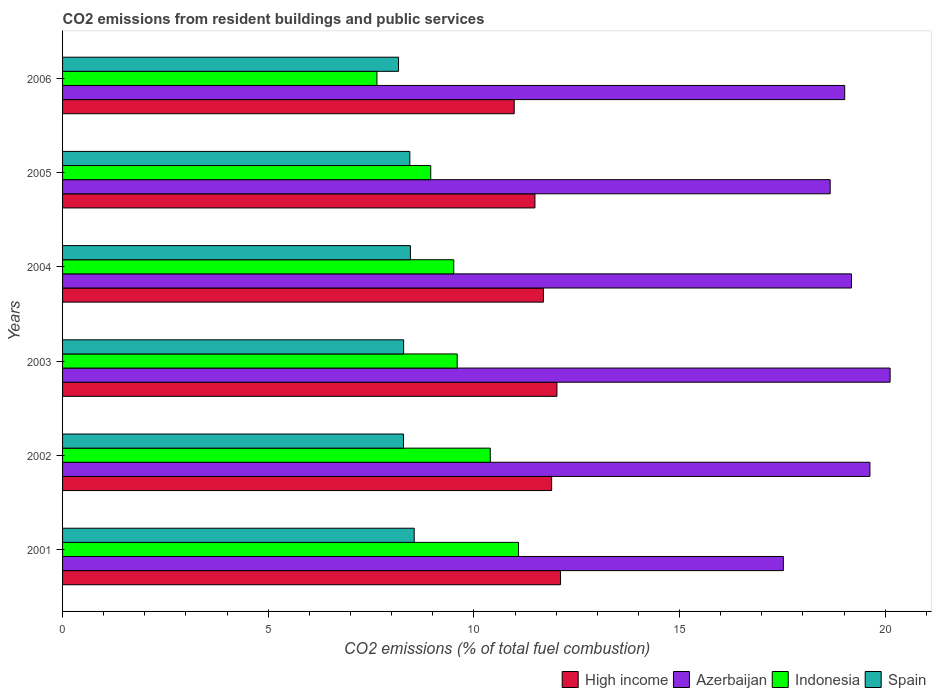How many different coloured bars are there?
Keep it short and to the point. 4. How many groups of bars are there?
Provide a short and direct response. 6. Are the number of bars per tick equal to the number of legend labels?
Offer a terse response. Yes. Are the number of bars on each tick of the Y-axis equal?
Make the answer very short. Yes. How many bars are there on the 2nd tick from the bottom?
Ensure brevity in your answer.  4. What is the label of the 3rd group of bars from the top?
Give a very brief answer. 2004. What is the total CO2 emitted in High income in 2005?
Your answer should be very brief. 11.48. Across all years, what is the maximum total CO2 emitted in Spain?
Make the answer very short. 8.55. Across all years, what is the minimum total CO2 emitted in High income?
Give a very brief answer. 10.98. What is the total total CO2 emitted in High income in the graph?
Your response must be concise. 70.17. What is the difference between the total CO2 emitted in Indonesia in 2003 and that in 2004?
Keep it short and to the point. 0.08. What is the difference between the total CO2 emitted in Azerbaijan in 2001 and the total CO2 emitted in Spain in 2002?
Provide a succinct answer. 9.24. What is the average total CO2 emitted in Azerbaijan per year?
Ensure brevity in your answer.  19.02. In the year 2004, what is the difference between the total CO2 emitted in Spain and total CO2 emitted in Azerbaijan?
Provide a succinct answer. -10.72. In how many years, is the total CO2 emitted in Azerbaijan greater than 5 ?
Make the answer very short. 6. What is the ratio of the total CO2 emitted in Spain in 2003 to that in 2006?
Your response must be concise. 1.02. Is the difference between the total CO2 emitted in Spain in 2002 and 2006 greater than the difference between the total CO2 emitted in Azerbaijan in 2002 and 2006?
Offer a terse response. No. What is the difference between the highest and the second highest total CO2 emitted in Spain?
Keep it short and to the point. 0.09. What is the difference between the highest and the lowest total CO2 emitted in Spain?
Keep it short and to the point. 0.38. In how many years, is the total CO2 emitted in Azerbaijan greater than the average total CO2 emitted in Azerbaijan taken over all years?
Your answer should be compact. 3. Is it the case that in every year, the sum of the total CO2 emitted in High income and total CO2 emitted in Azerbaijan is greater than the sum of total CO2 emitted in Spain and total CO2 emitted in Indonesia?
Your answer should be very brief. No. What does the 4th bar from the bottom in 2003 represents?
Keep it short and to the point. Spain. Is it the case that in every year, the sum of the total CO2 emitted in Spain and total CO2 emitted in Azerbaijan is greater than the total CO2 emitted in High income?
Make the answer very short. Yes. Are all the bars in the graph horizontal?
Your answer should be very brief. Yes. How many years are there in the graph?
Ensure brevity in your answer.  6. Does the graph contain grids?
Offer a terse response. No. What is the title of the graph?
Keep it short and to the point. CO2 emissions from resident buildings and public services. What is the label or title of the X-axis?
Your response must be concise. CO2 emissions (% of total fuel combustion). What is the CO2 emissions (% of total fuel combustion) of High income in 2001?
Your response must be concise. 12.11. What is the CO2 emissions (% of total fuel combustion) in Azerbaijan in 2001?
Your answer should be very brief. 17.52. What is the CO2 emissions (% of total fuel combustion) in Indonesia in 2001?
Make the answer very short. 11.09. What is the CO2 emissions (% of total fuel combustion) of Spain in 2001?
Offer a terse response. 8.55. What is the CO2 emissions (% of total fuel combustion) in High income in 2002?
Your answer should be very brief. 11.89. What is the CO2 emissions (% of total fuel combustion) in Azerbaijan in 2002?
Your response must be concise. 19.63. What is the CO2 emissions (% of total fuel combustion) in Indonesia in 2002?
Offer a terse response. 10.4. What is the CO2 emissions (% of total fuel combustion) in Spain in 2002?
Give a very brief answer. 8.29. What is the CO2 emissions (% of total fuel combustion) in High income in 2003?
Your response must be concise. 12.02. What is the CO2 emissions (% of total fuel combustion) of Azerbaijan in 2003?
Give a very brief answer. 20.12. What is the CO2 emissions (% of total fuel combustion) of Indonesia in 2003?
Provide a short and direct response. 9.59. What is the CO2 emissions (% of total fuel combustion) of Spain in 2003?
Offer a very short reply. 8.29. What is the CO2 emissions (% of total fuel combustion) in High income in 2004?
Your answer should be compact. 11.69. What is the CO2 emissions (% of total fuel combustion) in Azerbaijan in 2004?
Offer a terse response. 19.18. What is the CO2 emissions (% of total fuel combustion) of Indonesia in 2004?
Give a very brief answer. 9.51. What is the CO2 emissions (% of total fuel combustion) of Spain in 2004?
Make the answer very short. 8.46. What is the CO2 emissions (% of total fuel combustion) of High income in 2005?
Offer a very short reply. 11.48. What is the CO2 emissions (% of total fuel combustion) in Azerbaijan in 2005?
Make the answer very short. 18.66. What is the CO2 emissions (% of total fuel combustion) in Indonesia in 2005?
Your response must be concise. 8.95. What is the CO2 emissions (% of total fuel combustion) in Spain in 2005?
Provide a succinct answer. 8.44. What is the CO2 emissions (% of total fuel combustion) in High income in 2006?
Offer a very short reply. 10.98. What is the CO2 emissions (% of total fuel combustion) of Azerbaijan in 2006?
Your answer should be compact. 19.02. What is the CO2 emissions (% of total fuel combustion) in Indonesia in 2006?
Offer a very short reply. 7.64. What is the CO2 emissions (% of total fuel combustion) of Spain in 2006?
Give a very brief answer. 8.17. Across all years, what is the maximum CO2 emissions (% of total fuel combustion) of High income?
Offer a terse response. 12.11. Across all years, what is the maximum CO2 emissions (% of total fuel combustion) in Azerbaijan?
Offer a terse response. 20.12. Across all years, what is the maximum CO2 emissions (% of total fuel combustion) of Indonesia?
Your answer should be compact. 11.09. Across all years, what is the maximum CO2 emissions (% of total fuel combustion) in Spain?
Your answer should be compact. 8.55. Across all years, what is the minimum CO2 emissions (% of total fuel combustion) of High income?
Make the answer very short. 10.98. Across all years, what is the minimum CO2 emissions (% of total fuel combustion) of Azerbaijan?
Keep it short and to the point. 17.52. Across all years, what is the minimum CO2 emissions (% of total fuel combustion) of Indonesia?
Your response must be concise. 7.64. Across all years, what is the minimum CO2 emissions (% of total fuel combustion) of Spain?
Give a very brief answer. 8.17. What is the total CO2 emissions (% of total fuel combustion) of High income in the graph?
Provide a short and direct response. 70.17. What is the total CO2 emissions (% of total fuel combustion) in Azerbaijan in the graph?
Your response must be concise. 114.13. What is the total CO2 emissions (% of total fuel combustion) of Indonesia in the graph?
Make the answer very short. 57.18. What is the total CO2 emissions (% of total fuel combustion) in Spain in the graph?
Your answer should be compact. 50.2. What is the difference between the CO2 emissions (% of total fuel combustion) of High income in 2001 and that in 2002?
Ensure brevity in your answer.  0.22. What is the difference between the CO2 emissions (% of total fuel combustion) in Azerbaijan in 2001 and that in 2002?
Make the answer very short. -2.1. What is the difference between the CO2 emissions (% of total fuel combustion) in Indonesia in 2001 and that in 2002?
Provide a short and direct response. 0.69. What is the difference between the CO2 emissions (% of total fuel combustion) of Spain in 2001 and that in 2002?
Your answer should be compact. 0.26. What is the difference between the CO2 emissions (% of total fuel combustion) in High income in 2001 and that in 2003?
Keep it short and to the point. 0.09. What is the difference between the CO2 emissions (% of total fuel combustion) of Azerbaijan in 2001 and that in 2003?
Offer a very short reply. -2.6. What is the difference between the CO2 emissions (% of total fuel combustion) in Indonesia in 2001 and that in 2003?
Give a very brief answer. 1.49. What is the difference between the CO2 emissions (% of total fuel combustion) of Spain in 2001 and that in 2003?
Offer a very short reply. 0.26. What is the difference between the CO2 emissions (% of total fuel combustion) of High income in 2001 and that in 2004?
Ensure brevity in your answer.  0.42. What is the difference between the CO2 emissions (% of total fuel combustion) in Azerbaijan in 2001 and that in 2004?
Keep it short and to the point. -1.66. What is the difference between the CO2 emissions (% of total fuel combustion) in Indonesia in 2001 and that in 2004?
Your response must be concise. 1.58. What is the difference between the CO2 emissions (% of total fuel combustion) of Spain in 2001 and that in 2004?
Offer a terse response. 0.09. What is the difference between the CO2 emissions (% of total fuel combustion) in High income in 2001 and that in 2005?
Offer a very short reply. 0.62. What is the difference between the CO2 emissions (% of total fuel combustion) in Azerbaijan in 2001 and that in 2005?
Offer a very short reply. -1.14. What is the difference between the CO2 emissions (% of total fuel combustion) of Indonesia in 2001 and that in 2005?
Your response must be concise. 2.13. What is the difference between the CO2 emissions (% of total fuel combustion) in Spain in 2001 and that in 2005?
Your response must be concise. 0.11. What is the difference between the CO2 emissions (% of total fuel combustion) in High income in 2001 and that in 2006?
Ensure brevity in your answer.  1.13. What is the difference between the CO2 emissions (% of total fuel combustion) in Azerbaijan in 2001 and that in 2006?
Ensure brevity in your answer.  -1.49. What is the difference between the CO2 emissions (% of total fuel combustion) in Indonesia in 2001 and that in 2006?
Your response must be concise. 3.44. What is the difference between the CO2 emissions (% of total fuel combustion) in Spain in 2001 and that in 2006?
Your response must be concise. 0.38. What is the difference between the CO2 emissions (% of total fuel combustion) of High income in 2002 and that in 2003?
Keep it short and to the point. -0.13. What is the difference between the CO2 emissions (% of total fuel combustion) in Azerbaijan in 2002 and that in 2003?
Your answer should be very brief. -0.49. What is the difference between the CO2 emissions (% of total fuel combustion) in Indonesia in 2002 and that in 2003?
Keep it short and to the point. 0.8. What is the difference between the CO2 emissions (% of total fuel combustion) in Spain in 2002 and that in 2003?
Offer a very short reply. -0. What is the difference between the CO2 emissions (% of total fuel combustion) of High income in 2002 and that in 2004?
Provide a succinct answer. 0.2. What is the difference between the CO2 emissions (% of total fuel combustion) of Azerbaijan in 2002 and that in 2004?
Your answer should be compact. 0.45. What is the difference between the CO2 emissions (% of total fuel combustion) in Indonesia in 2002 and that in 2004?
Your response must be concise. 0.89. What is the difference between the CO2 emissions (% of total fuel combustion) in Spain in 2002 and that in 2004?
Make the answer very short. -0.17. What is the difference between the CO2 emissions (% of total fuel combustion) of High income in 2002 and that in 2005?
Your response must be concise. 0.41. What is the difference between the CO2 emissions (% of total fuel combustion) in Azerbaijan in 2002 and that in 2005?
Offer a terse response. 0.97. What is the difference between the CO2 emissions (% of total fuel combustion) in Indonesia in 2002 and that in 2005?
Your answer should be compact. 1.45. What is the difference between the CO2 emissions (% of total fuel combustion) of Spain in 2002 and that in 2005?
Make the answer very short. -0.15. What is the difference between the CO2 emissions (% of total fuel combustion) in High income in 2002 and that in 2006?
Give a very brief answer. 0.91. What is the difference between the CO2 emissions (% of total fuel combustion) of Azerbaijan in 2002 and that in 2006?
Offer a very short reply. 0.61. What is the difference between the CO2 emissions (% of total fuel combustion) of Indonesia in 2002 and that in 2006?
Your answer should be very brief. 2.76. What is the difference between the CO2 emissions (% of total fuel combustion) of Spain in 2002 and that in 2006?
Give a very brief answer. 0.12. What is the difference between the CO2 emissions (% of total fuel combustion) in High income in 2003 and that in 2004?
Your response must be concise. 0.33. What is the difference between the CO2 emissions (% of total fuel combustion) of Azerbaijan in 2003 and that in 2004?
Your response must be concise. 0.94. What is the difference between the CO2 emissions (% of total fuel combustion) in Indonesia in 2003 and that in 2004?
Offer a terse response. 0.08. What is the difference between the CO2 emissions (% of total fuel combustion) of Spain in 2003 and that in 2004?
Offer a very short reply. -0.17. What is the difference between the CO2 emissions (% of total fuel combustion) of High income in 2003 and that in 2005?
Offer a very short reply. 0.53. What is the difference between the CO2 emissions (% of total fuel combustion) in Azerbaijan in 2003 and that in 2005?
Provide a short and direct response. 1.46. What is the difference between the CO2 emissions (% of total fuel combustion) in Indonesia in 2003 and that in 2005?
Your answer should be compact. 0.64. What is the difference between the CO2 emissions (% of total fuel combustion) in Spain in 2003 and that in 2005?
Offer a very short reply. -0.15. What is the difference between the CO2 emissions (% of total fuel combustion) of High income in 2003 and that in 2006?
Give a very brief answer. 1.04. What is the difference between the CO2 emissions (% of total fuel combustion) of Azerbaijan in 2003 and that in 2006?
Give a very brief answer. 1.1. What is the difference between the CO2 emissions (% of total fuel combustion) in Indonesia in 2003 and that in 2006?
Ensure brevity in your answer.  1.95. What is the difference between the CO2 emissions (% of total fuel combustion) of Spain in 2003 and that in 2006?
Your answer should be very brief. 0.12. What is the difference between the CO2 emissions (% of total fuel combustion) in High income in 2004 and that in 2005?
Make the answer very short. 0.21. What is the difference between the CO2 emissions (% of total fuel combustion) in Azerbaijan in 2004 and that in 2005?
Keep it short and to the point. 0.52. What is the difference between the CO2 emissions (% of total fuel combustion) in Indonesia in 2004 and that in 2005?
Keep it short and to the point. 0.56. What is the difference between the CO2 emissions (% of total fuel combustion) of Spain in 2004 and that in 2005?
Give a very brief answer. 0.01. What is the difference between the CO2 emissions (% of total fuel combustion) in High income in 2004 and that in 2006?
Give a very brief answer. 0.71. What is the difference between the CO2 emissions (% of total fuel combustion) of Azerbaijan in 2004 and that in 2006?
Offer a very short reply. 0.16. What is the difference between the CO2 emissions (% of total fuel combustion) of Indonesia in 2004 and that in 2006?
Offer a very short reply. 1.87. What is the difference between the CO2 emissions (% of total fuel combustion) in Spain in 2004 and that in 2006?
Your answer should be compact. 0.29. What is the difference between the CO2 emissions (% of total fuel combustion) of High income in 2005 and that in 2006?
Offer a very short reply. 0.5. What is the difference between the CO2 emissions (% of total fuel combustion) of Azerbaijan in 2005 and that in 2006?
Make the answer very short. -0.35. What is the difference between the CO2 emissions (% of total fuel combustion) in Indonesia in 2005 and that in 2006?
Keep it short and to the point. 1.31. What is the difference between the CO2 emissions (% of total fuel combustion) in Spain in 2005 and that in 2006?
Make the answer very short. 0.27. What is the difference between the CO2 emissions (% of total fuel combustion) of High income in 2001 and the CO2 emissions (% of total fuel combustion) of Azerbaijan in 2002?
Your answer should be very brief. -7.52. What is the difference between the CO2 emissions (% of total fuel combustion) of High income in 2001 and the CO2 emissions (% of total fuel combustion) of Indonesia in 2002?
Offer a very short reply. 1.71. What is the difference between the CO2 emissions (% of total fuel combustion) of High income in 2001 and the CO2 emissions (% of total fuel combustion) of Spain in 2002?
Your answer should be compact. 3.82. What is the difference between the CO2 emissions (% of total fuel combustion) in Azerbaijan in 2001 and the CO2 emissions (% of total fuel combustion) in Indonesia in 2002?
Offer a terse response. 7.13. What is the difference between the CO2 emissions (% of total fuel combustion) of Azerbaijan in 2001 and the CO2 emissions (% of total fuel combustion) of Spain in 2002?
Offer a terse response. 9.24. What is the difference between the CO2 emissions (% of total fuel combustion) in Indonesia in 2001 and the CO2 emissions (% of total fuel combustion) in Spain in 2002?
Your response must be concise. 2.8. What is the difference between the CO2 emissions (% of total fuel combustion) in High income in 2001 and the CO2 emissions (% of total fuel combustion) in Azerbaijan in 2003?
Offer a very short reply. -8.01. What is the difference between the CO2 emissions (% of total fuel combustion) of High income in 2001 and the CO2 emissions (% of total fuel combustion) of Indonesia in 2003?
Your response must be concise. 2.51. What is the difference between the CO2 emissions (% of total fuel combustion) in High income in 2001 and the CO2 emissions (% of total fuel combustion) in Spain in 2003?
Keep it short and to the point. 3.82. What is the difference between the CO2 emissions (% of total fuel combustion) in Azerbaijan in 2001 and the CO2 emissions (% of total fuel combustion) in Indonesia in 2003?
Offer a very short reply. 7.93. What is the difference between the CO2 emissions (% of total fuel combustion) of Azerbaijan in 2001 and the CO2 emissions (% of total fuel combustion) of Spain in 2003?
Offer a very short reply. 9.23. What is the difference between the CO2 emissions (% of total fuel combustion) of Indonesia in 2001 and the CO2 emissions (% of total fuel combustion) of Spain in 2003?
Offer a terse response. 2.79. What is the difference between the CO2 emissions (% of total fuel combustion) in High income in 2001 and the CO2 emissions (% of total fuel combustion) in Azerbaijan in 2004?
Give a very brief answer. -7.07. What is the difference between the CO2 emissions (% of total fuel combustion) in High income in 2001 and the CO2 emissions (% of total fuel combustion) in Indonesia in 2004?
Your answer should be compact. 2.6. What is the difference between the CO2 emissions (% of total fuel combustion) in High income in 2001 and the CO2 emissions (% of total fuel combustion) in Spain in 2004?
Keep it short and to the point. 3.65. What is the difference between the CO2 emissions (% of total fuel combustion) in Azerbaijan in 2001 and the CO2 emissions (% of total fuel combustion) in Indonesia in 2004?
Offer a terse response. 8.01. What is the difference between the CO2 emissions (% of total fuel combustion) in Azerbaijan in 2001 and the CO2 emissions (% of total fuel combustion) in Spain in 2004?
Ensure brevity in your answer.  9.07. What is the difference between the CO2 emissions (% of total fuel combustion) in Indonesia in 2001 and the CO2 emissions (% of total fuel combustion) in Spain in 2004?
Your response must be concise. 2.63. What is the difference between the CO2 emissions (% of total fuel combustion) in High income in 2001 and the CO2 emissions (% of total fuel combustion) in Azerbaijan in 2005?
Give a very brief answer. -6.56. What is the difference between the CO2 emissions (% of total fuel combustion) of High income in 2001 and the CO2 emissions (% of total fuel combustion) of Indonesia in 2005?
Provide a succinct answer. 3.16. What is the difference between the CO2 emissions (% of total fuel combustion) of High income in 2001 and the CO2 emissions (% of total fuel combustion) of Spain in 2005?
Your answer should be very brief. 3.66. What is the difference between the CO2 emissions (% of total fuel combustion) in Azerbaijan in 2001 and the CO2 emissions (% of total fuel combustion) in Indonesia in 2005?
Give a very brief answer. 8.57. What is the difference between the CO2 emissions (% of total fuel combustion) in Azerbaijan in 2001 and the CO2 emissions (% of total fuel combustion) in Spain in 2005?
Offer a very short reply. 9.08. What is the difference between the CO2 emissions (% of total fuel combustion) in Indonesia in 2001 and the CO2 emissions (% of total fuel combustion) in Spain in 2005?
Make the answer very short. 2.64. What is the difference between the CO2 emissions (% of total fuel combustion) in High income in 2001 and the CO2 emissions (% of total fuel combustion) in Azerbaijan in 2006?
Provide a short and direct response. -6.91. What is the difference between the CO2 emissions (% of total fuel combustion) in High income in 2001 and the CO2 emissions (% of total fuel combustion) in Indonesia in 2006?
Give a very brief answer. 4.46. What is the difference between the CO2 emissions (% of total fuel combustion) in High income in 2001 and the CO2 emissions (% of total fuel combustion) in Spain in 2006?
Your answer should be very brief. 3.94. What is the difference between the CO2 emissions (% of total fuel combustion) in Azerbaijan in 2001 and the CO2 emissions (% of total fuel combustion) in Indonesia in 2006?
Provide a short and direct response. 9.88. What is the difference between the CO2 emissions (% of total fuel combustion) of Azerbaijan in 2001 and the CO2 emissions (% of total fuel combustion) of Spain in 2006?
Your response must be concise. 9.36. What is the difference between the CO2 emissions (% of total fuel combustion) in Indonesia in 2001 and the CO2 emissions (% of total fuel combustion) in Spain in 2006?
Provide a short and direct response. 2.92. What is the difference between the CO2 emissions (% of total fuel combustion) of High income in 2002 and the CO2 emissions (% of total fuel combustion) of Azerbaijan in 2003?
Provide a succinct answer. -8.23. What is the difference between the CO2 emissions (% of total fuel combustion) in High income in 2002 and the CO2 emissions (% of total fuel combustion) in Indonesia in 2003?
Ensure brevity in your answer.  2.3. What is the difference between the CO2 emissions (% of total fuel combustion) of High income in 2002 and the CO2 emissions (% of total fuel combustion) of Spain in 2003?
Your answer should be compact. 3.6. What is the difference between the CO2 emissions (% of total fuel combustion) in Azerbaijan in 2002 and the CO2 emissions (% of total fuel combustion) in Indonesia in 2003?
Give a very brief answer. 10.04. What is the difference between the CO2 emissions (% of total fuel combustion) in Azerbaijan in 2002 and the CO2 emissions (% of total fuel combustion) in Spain in 2003?
Offer a terse response. 11.34. What is the difference between the CO2 emissions (% of total fuel combustion) in Indonesia in 2002 and the CO2 emissions (% of total fuel combustion) in Spain in 2003?
Provide a succinct answer. 2.11. What is the difference between the CO2 emissions (% of total fuel combustion) in High income in 2002 and the CO2 emissions (% of total fuel combustion) in Azerbaijan in 2004?
Your answer should be very brief. -7.29. What is the difference between the CO2 emissions (% of total fuel combustion) of High income in 2002 and the CO2 emissions (% of total fuel combustion) of Indonesia in 2004?
Provide a succinct answer. 2.38. What is the difference between the CO2 emissions (% of total fuel combustion) in High income in 2002 and the CO2 emissions (% of total fuel combustion) in Spain in 2004?
Give a very brief answer. 3.43. What is the difference between the CO2 emissions (% of total fuel combustion) in Azerbaijan in 2002 and the CO2 emissions (% of total fuel combustion) in Indonesia in 2004?
Make the answer very short. 10.12. What is the difference between the CO2 emissions (% of total fuel combustion) in Azerbaijan in 2002 and the CO2 emissions (% of total fuel combustion) in Spain in 2004?
Provide a short and direct response. 11.17. What is the difference between the CO2 emissions (% of total fuel combustion) of Indonesia in 2002 and the CO2 emissions (% of total fuel combustion) of Spain in 2004?
Offer a terse response. 1.94. What is the difference between the CO2 emissions (% of total fuel combustion) in High income in 2002 and the CO2 emissions (% of total fuel combustion) in Azerbaijan in 2005?
Your response must be concise. -6.77. What is the difference between the CO2 emissions (% of total fuel combustion) in High income in 2002 and the CO2 emissions (% of total fuel combustion) in Indonesia in 2005?
Your answer should be very brief. 2.94. What is the difference between the CO2 emissions (% of total fuel combustion) of High income in 2002 and the CO2 emissions (% of total fuel combustion) of Spain in 2005?
Your response must be concise. 3.45. What is the difference between the CO2 emissions (% of total fuel combustion) of Azerbaijan in 2002 and the CO2 emissions (% of total fuel combustion) of Indonesia in 2005?
Keep it short and to the point. 10.68. What is the difference between the CO2 emissions (% of total fuel combustion) of Azerbaijan in 2002 and the CO2 emissions (% of total fuel combustion) of Spain in 2005?
Your answer should be very brief. 11.19. What is the difference between the CO2 emissions (% of total fuel combustion) of Indonesia in 2002 and the CO2 emissions (% of total fuel combustion) of Spain in 2005?
Your answer should be compact. 1.96. What is the difference between the CO2 emissions (% of total fuel combustion) in High income in 2002 and the CO2 emissions (% of total fuel combustion) in Azerbaijan in 2006?
Your response must be concise. -7.13. What is the difference between the CO2 emissions (% of total fuel combustion) in High income in 2002 and the CO2 emissions (% of total fuel combustion) in Indonesia in 2006?
Ensure brevity in your answer.  4.25. What is the difference between the CO2 emissions (% of total fuel combustion) in High income in 2002 and the CO2 emissions (% of total fuel combustion) in Spain in 2006?
Ensure brevity in your answer.  3.72. What is the difference between the CO2 emissions (% of total fuel combustion) of Azerbaijan in 2002 and the CO2 emissions (% of total fuel combustion) of Indonesia in 2006?
Your answer should be very brief. 11.99. What is the difference between the CO2 emissions (% of total fuel combustion) of Azerbaijan in 2002 and the CO2 emissions (% of total fuel combustion) of Spain in 2006?
Your response must be concise. 11.46. What is the difference between the CO2 emissions (% of total fuel combustion) of Indonesia in 2002 and the CO2 emissions (% of total fuel combustion) of Spain in 2006?
Make the answer very short. 2.23. What is the difference between the CO2 emissions (% of total fuel combustion) of High income in 2003 and the CO2 emissions (% of total fuel combustion) of Azerbaijan in 2004?
Give a very brief answer. -7.16. What is the difference between the CO2 emissions (% of total fuel combustion) in High income in 2003 and the CO2 emissions (% of total fuel combustion) in Indonesia in 2004?
Ensure brevity in your answer.  2.51. What is the difference between the CO2 emissions (% of total fuel combustion) in High income in 2003 and the CO2 emissions (% of total fuel combustion) in Spain in 2004?
Offer a terse response. 3.56. What is the difference between the CO2 emissions (% of total fuel combustion) in Azerbaijan in 2003 and the CO2 emissions (% of total fuel combustion) in Indonesia in 2004?
Offer a very short reply. 10.61. What is the difference between the CO2 emissions (% of total fuel combustion) of Azerbaijan in 2003 and the CO2 emissions (% of total fuel combustion) of Spain in 2004?
Offer a terse response. 11.66. What is the difference between the CO2 emissions (% of total fuel combustion) in Indonesia in 2003 and the CO2 emissions (% of total fuel combustion) in Spain in 2004?
Your answer should be compact. 1.14. What is the difference between the CO2 emissions (% of total fuel combustion) of High income in 2003 and the CO2 emissions (% of total fuel combustion) of Azerbaijan in 2005?
Provide a short and direct response. -6.64. What is the difference between the CO2 emissions (% of total fuel combustion) in High income in 2003 and the CO2 emissions (% of total fuel combustion) in Indonesia in 2005?
Ensure brevity in your answer.  3.07. What is the difference between the CO2 emissions (% of total fuel combustion) of High income in 2003 and the CO2 emissions (% of total fuel combustion) of Spain in 2005?
Your response must be concise. 3.58. What is the difference between the CO2 emissions (% of total fuel combustion) of Azerbaijan in 2003 and the CO2 emissions (% of total fuel combustion) of Indonesia in 2005?
Provide a succinct answer. 11.17. What is the difference between the CO2 emissions (% of total fuel combustion) in Azerbaijan in 2003 and the CO2 emissions (% of total fuel combustion) in Spain in 2005?
Provide a short and direct response. 11.68. What is the difference between the CO2 emissions (% of total fuel combustion) of Indonesia in 2003 and the CO2 emissions (% of total fuel combustion) of Spain in 2005?
Keep it short and to the point. 1.15. What is the difference between the CO2 emissions (% of total fuel combustion) of High income in 2003 and the CO2 emissions (% of total fuel combustion) of Azerbaijan in 2006?
Provide a succinct answer. -7. What is the difference between the CO2 emissions (% of total fuel combustion) in High income in 2003 and the CO2 emissions (% of total fuel combustion) in Indonesia in 2006?
Give a very brief answer. 4.38. What is the difference between the CO2 emissions (% of total fuel combustion) of High income in 2003 and the CO2 emissions (% of total fuel combustion) of Spain in 2006?
Offer a terse response. 3.85. What is the difference between the CO2 emissions (% of total fuel combustion) of Azerbaijan in 2003 and the CO2 emissions (% of total fuel combustion) of Indonesia in 2006?
Offer a terse response. 12.48. What is the difference between the CO2 emissions (% of total fuel combustion) in Azerbaijan in 2003 and the CO2 emissions (% of total fuel combustion) in Spain in 2006?
Make the answer very short. 11.95. What is the difference between the CO2 emissions (% of total fuel combustion) in Indonesia in 2003 and the CO2 emissions (% of total fuel combustion) in Spain in 2006?
Make the answer very short. 1.43. What is the difference between the CO2 emissions (% of total fuel combustion) in High income in 2004 and the CO2 emissions (% of total fuel combustion) in Azerbaijan in 2005?
Provide a succinct answer. -6.97. What is the difference between the CO2 emissions (% of total fuel combustion) in High income in 2004 and the CO2 emissions (% of total fuel combustion) in Indonesia in 2005?
Ensure brevity in your answer.  2.74. What is the difference between the CO2 emissions (% of total fuel combustion) of High income in 2004 and the CO2 emissions (% of total fuel combustion) of Spain in 2005?
Provide a short and direct response. 3.25. What is the difference between the CO2 emissions (% of total fuel combustion) in Azerbaijan in 2004 and the CO2 emissions (% of total fuel combustion) in Indonesia in 2005?
Your answer should be very brief. 10.23. What is the difference between the CO2 emissions (% of total fuel combustion) in Azerbaijan in 2004 and the CO2 emissions (% of total fuel combustion) in Spain in 2005?
Offer a terse response. 10.74. What is the difference between the CO2 emissions (% of total fuel combustion) of Indonesia in 2004 and the CO2 emissions (% of total fuel combustion) of Spain in 2005?
Provide a succinct answer. 1.07. What is the difference between the CO2 emissions (% of total fuel combustion) of High income in 2004 and the CO2 emissions (% of total fuel combustion) of Azerbaijan in 2006?
Ensure brevity in your answer.  -7.33. What is the difference between the CO2 emissions (% of total fuel combustion) in High income in 2004 and the CO2 emissions (% of total fuel combustion) in Indonesia in 2006?
Offer a very short reply. 4.05. What is the difference between the CO2 emissions (% of total fuel combustion) in High income in 2004 and the CO2 emissions (% of total fuel combustion) in Spain in 2006?
Offer a very short reply. 3.52. What is the difference between the CO2 emissions (% of total fuel combustion) in Azerbaijan in 2004 and the CO2 emissions (% of total fuel combustion) in Indonesia in 2006?
Make the answer very short. 11.54. What is the difference between the CO2 emissions (% of total fuel combustion) of Azerbaijan in 2004 and the CO2 emissions (% of total fuel combustion) of Spain in 2006?
Ensure brevity in your answer.  11.01. What is the difference between the CO2 emissions (% of total fuel combustion) of Indonesia in 2004 and the CO2 emissions (% of total fuel combustion) of Spain in 2006?
Offer a terse response. 1.34. What is the difference between the CO2 emissions (% of total fuel combustion) of High income in 2005 and the CO2 emissions (% of total fuel combustion) of Azerbaijan in 2006?
Make the answer very short. -7.53. What is the difference between the CO2 emissions (% of total fuel combustion) of High income in 2005 and the CO2 emissions (% of total fuel combustion) of Indonesia in 2006?
Your answer should be compact. 3.84. What is the difference between the CO2 emissions (% of total fuel combustion) of High income in 2005 and the CO2 emissions (% of total fuel combustion) of Spain in 2006?
Offer a very short reply. 3.32. What is the difference between the CO2 emissions (% of total fuel combustion) of Azerbaijan in 2005 and the CO2 emissions (% of total fuel combustion) of Indonesia in 2006?
Offer a very short reply. 11.02. What is the difference between the CO2 emissions (% of total fuel combustion) of Azerbaijan in 2005 and the CO2 emissions (% of total fuel combustion) of Spain in 2006?
Offer a very short reply. 10.49. What is the difference between the CO2 emissions (% of total fuel combustion) in Indonesia in 2005 and the CO2 emissions (% of total fuel combustion) in Spain in 2006?
Your answer should be compact. 0.78. What is the average CO2 emissions (% of total fuel combustion) of High income per year?
Provide a short and direct response. 11.7. What is the average CO2 emissions (% of total fuel combustion) of Azerbaijan per year?
Provide a short and direct response. 19.02. What is the average CO2 emissions (% of total fuel combustion) in Indonesia per year?
Offer a terse response. 9.53. What is the average CO2 emissions (% of total fuel combustion) in Spain per year?
Keep it short and to the point. 8.37. In the year 2001, what is the difference between the CO2 emissions (% of total fuel combustion) of High income and CO2 emissions (% of total fuel combustion) of Azerbaijan?
Your answer should be compact. -5.42. In the year 2001, what is the difference between the CO2 emissions (% of total fuel combustion) of High income and CO2 emissions (% of total fuel combustion) of Indonesia?
Provide a succinct answer. 1.02. In the year 2001, what is the difference between the CO2 emissions (% of total fuel combustion) of High income and CO2 emissions (% of total fuel combustion) of Spain?
Your answer should be very brief. 3.56. In the year 2001, what is the difference between the CO2 emissions (% of total fuel combustion) of Azerbaijan and CO2 emissions (% of total fuel combustion) of Indonesia?
Provide a succinct answer. 6.44. In the year 2001, what is the difference between the CO2 emissions (% of total fuel combustion) in Azerbaijan and CO2 emissions (% of total fuel combustion) in Spain?
Your response must be concise. 8.98. In the year 2001, what is the difference between the CO2 emissions (% of total fuel combustion) in Indonesia and CO2 emissions (% of total fuel combustion) in Spain?
Keep it short and to the point. 2.54. In the year 2002, what is the difference between the CO2 emissions (% of total fuel combustion) of High income and CO2 emissions (% of total fuel combustion) of Azerbaijan?
Your response must be concise. -7.74. In the year 2002, what is the difference between the CO2 emissions (% of total fuel combustion) in High income and CO2 emissions (% of total fuel combustion) in Indonesia?
Provide a short and direct response. 1.49. In the year 2002, what is the difference between the CO2 emissions (% of total fuel combustion) in High income and CO2 emissions (% of total fuel combustion) in Spain?
Offer a very short reply. 3.6. In the year 2002, what is the difference between the CO2 emissions (% of total fuel combustion) in Azerbaijan and CO2 emissions (% of total fuel combustion) in Indonesia?
Make the answer very short. 9.23. In the year 2002, what is the difference between the CO2 emissions (% of total fuel combustion) of Azerbaijan and CO2 emissions (% of total fuel combustion) of Spain?
Make the answer very short. 11.34. In the year 2002, what is the difference between the CO2 emissions (% of total fuel combustion) in Indonesia and CO2 emissions (% of total fuel combustion) in Spain?
Your answer should be very brief. 2.11. In the year 2003, what is the difference between the CO2 emissions (% of total fuel combustion) in High income and CO2 emissions (% of total fuel combustion) in Azerbaijan?
Make the answer very short. -8.1. In the year 2003, what is the difference between the CO2 emissions (% of total fuel combustion) of High income and CO2 emissions (% of total fuel combustion) of Indonesia?
Offer a very short reply. 2.43. In the year 2003, what is the difference between the CO2 emissions (% of total fuel combustion) in High income and CO2 emissions (% of total fuel combustion) in Spain?
Make the answer very short. 3.73. In the year 2003, what is the difference between the CO2 emissions (% of total fuel combustion) of Azerbaijan and CO2 emissions (% of total fuel combustion) of Indonesia?
Your answer should be compact. 10.53. In the year 2003, what is the difference between the CO2 emissions (% of total fuel combustion) in Azerbaijan and CO2 emissions (% of total fuel combustion) in Spain?
Offer a very short reply. 11.83. In the year 2003, what is the difference between the CO2 emissions (% of total fuel combustion) in Indonesia and CO2 emissions (% of total fuel combustion) in Spain?
Offer a terse response. 1.3. In the year 2004, what is the difference between the CO2 emissions (% of total fuel combustion) of High income and CO2 emissions (% of total fuel combustion) of Azerbaijan?
Provide a succinct answer. -7.49. In the year 2004, what is the difference between the CO2 emissions (% of total fuel combustion) in High income and CO2 emissions (% of total fuel combustion) in Indonesia?
Your response must be concise. 2.18. In the year 2004, what is the difference between the CO2 emissions (% of total fuel combustion) in High income and CO2 emissions (% of total fuel combustion) in Spain?
Provide a short and direct response. 3.23. In the year 2004, what is the difference between the CO2 emissions (% of total fuel combustion) of Azerbaijan and CO2 emissions (% of total fuel combustion) of Indonesia?
Your response must be concise. 9.67. In the year 2004, what is the difference between the CO2 emissions (% of total fuel combustion) of Azerbaijan and CO2 emissions (% of total fuel combustion) of Spain?
Offer a very short reply. 10.72. In the year 2004, what is the difference between the CO2 emissions (% of total fuel combustion) in Indonesia and CO2 emissions (% of total fuel combustion) in Spain?
Make the answer very short. 1.05. In the year 2005, what is the difference between the CO2 emissions (% of total fuel combustion) of High income and CO2 emissions (% of total fuel combustion) of Azerbaijan?
Give a very brief answer. -7.18. In the year 2005, what is the difference between the CO2 emissions (% of total fuel combustion) in High income and CO2 emissions (% of total fuel combustion) in Indonesia?
Provide a succinct answer. 2.53. In the year 2005, what is the difference between the CO2 emissions (% of total fuel combustion) of High income and CO2 emissions (% of total fuel combustion) of Spain?
Ensure brevity in your answer.  3.04. In the year 2005, what is the difference between the CO2 emissions (% of total fuel combustion) in Azerbaijan and CO2 emissions (% of total fuel combustion) in Indonesia?
Your answer should be very brief. 9.71. In the year 2005, what is the difference between the CO2 emissions (% of total fuel combustion) in Azerbaijan and CO2 emissions (% of total fuel combustion) in Spain?
Give a very brief answer. 10.22. In the year 2005, what is the difference between the CO2 emissions (% of total fuel combustion) in Indonesia and CO2 emissions (% of total fuel combustion) in Spain?
Offer a very short reply. 0.51. In the year 2006, what is the difference between the CO2 emissions (% of total fuel combustion) of High income and CO2 emissions (% of total fuel combustion) of Azerbaijan?
Provide a succinct answer. -8.04. In the year 2006, what is the difference between the CO2 emissions (% of total fuel combustion) of High income and CO2 emissions (% of total fuel combustion) of Indonesia?
Give a very brief answer. 3.34. In the year 2006, what is the difference between the CO2 emissions (% of total fuel combustion) of High income and CO2 emissions (% of total fuel combustion) of Spain?
Ensure brevity in your answer.  2.81. In the year 2006, what is the difference between the CO2 emissions (% of total fuel combustion) in Azerbaijan and CO2 emissions (% of total fuel combustion) in Indonesia?
Offer a terse response. 11.37. In the year 2006, what is the difference between the CO2 emissions (% of total fuel combustion) in Azerbaijan and CO2 emissions (% of total fuel combustion) in Spain?
Keep it short and to the point. 10.85. In the year 2006, what is the difference between the CO2 emissions (% of total fuel combustion) in Indonesia and CO2 emissions (% of total fuel combustion) in Spain?
Ensure brevity in your answer.  -0.53. What is the ratio of the CO2 emissions (% of total fuel combustion) of High income in 2001 to that in 2002?
Keep it short and to the point. 1.02. What is the ratio of the CO2 emissions (% of total fuel combustion) in Azerbaijan in 2001 to that in 2002?
Provide a short and direct response. 0.89. What is the ratio of the CO2 emissions (% of total fuel combustion) of Indonesia in 2001 to that in 2002?
Your answer should be compact. 1.07. What is the ratio of the CO2 emissions (% of total fuel combustion) in Spain in 2001 to that in 2002?
Make the answer very short. 1.03. What is the ratio of the CO2 emissions (% of total fuel combustion) in High income in 2001 to that in 2003?
Your response must be concise. 1.01. What is the ratio of the CO2 emissions (% of total fuel combustion) in Azerbaijan in 2001 to that in 2003?
Provide a succinct answer. 0.87. What is the ratio of the CO2 emissions (% of total fuel combustion) in Indonesia in 2001 to that in 2003?
Provide a short and direct response. 1.16. What is the ratio of the CO2 emissions (% of total fuel combustion) of Spain in 2001 to that in 2003?
Provide a succinct answer. 1.03. What is the ratio of the CO2 emissions (% of total fuel combustion) in High income in 2001 to that in 2004?
Provide a succinct answer. 1.04. What is the ratio of the CO2 emissions (% of total fuel combustion) of Azerbaijan in 2001 to that in 2004?
Ensure brevity in your answer.  0.91. What is the ratio of the CO2 emissions (% of total fuel combustion) in Indonesia in 2001 to that in 2004?
Ensure brevity in your answer.  1.17. What is the ratio of the CO2 emissions (% of total fuel combustion) in Spain in 2001 to that in 2004?
Keep it short and to the point. 1.01. What is the ratio of the CO2 emissions (% of total fuel combustion) of High income in 2001 to that in 2005?
Offer a very short reply. 1.05. What is the ratio of the CO2 emissions (% of total fuel combustion) of Azerbaijan in 2001 to that in 2005?
Provide a succinct answer. 0.94. What is the ratio of the CO2 emissions (% of total fuel combustion) in Indonesia in 2001 to that in 2005?
Ensure brevity in your answer.  1.24. What is the ratio of the CO2 emissions (% of total fuel combustion) of Spain in 2001 to that in 2005?
Offer a terse response. 1.01. What is the ratio of the CO2 emissions (% of total fuel combustion) of High income in 2001 to that in 2006?
Your answer should be compact. 1.1. What is the ratio of the CO2 emissions (% of total fuel combustion) of Azerbaijan in 2001 to that in 2006?
Keep it short and to the point. 0.92. What is the ratio of the CO2 emissions (% of total fuel combustion) of Indonesia in 2001 to that in 2006?
Ensure brevity in your answer.  1.45. What is the ratio of the CO2 emissions (% of total fuel combustion) of Spain in 2001 to that in 2006?
Provide a short and direct response. 1.05. What is the ratio of the CO2 emissions (% of total fuel combustion) in High income in 2002 to that in 2003?
Keep it short and to the point. 0.99. What is the ratio of the CO2 emissions (% of total fuel combustion) of Azerbaijan in 2002 to that in 2003?
Give a very brief answer. 0.98. What is the ratio of the CO2 emissions (% of total fuel combustion) of Indonesia in 2002 to that in 2003?
Offer a terse response. 1.08. What is the ratio of the CO2 emissions (% of total fuel combustion) of Spain in 2002 to that in 2003?
Your response must be concise. 1. What is the ratio of the CO2 emissions (% of total fuel combustion) in High income in 2002 to that in 2004?
Give a very brief answer. 1.02. What is the ratio of the CO2 emissions (% of total fuel combustion) in Azerbaijan in 2002 to that in 2004?
Offer a terse response. 1.02. What is the ratio of the CO2 emissions (% of total fuel combustion) in Indonesia in 2002 to that in 2004?
Ensure brevity in your answer.  1.09. What is the ratio of the CO2 emissions (% of total fuel combustion) of Spain in 2002 to that in 2004?
Provide a succinct answer. 0.98. What is the ratio of the CO2 emissions (% of total fuel combustion) of High income in 2002 to that in 2005?
Provide a succinct answer. 1.04. What is the ratio of the CO2 emissions (% of total fuel combustion) of Azerbaijan in 2002 to that in 2005?
Provide a short and direct response. 1.05. What is the ratio of the CO2 emissions (% of total fuel combustion) in Indonesia in 2002 to that in 2005?
Give a very brief answer. 1.16. What is the ratio of the CO2 emissions (% of total fuel combustion) of Spain in 2002 to that in 2005?
Offer a terse response. 0.98. What is the ratio of the CO2 emissions (% of total fuel combustion) of High income in 2002 to that in 2006?
Ensure brevity in your answer.  1.08. What is the ratio of the CO2 emissions (% of total fuel combustion) of Azerbaijan in 2002 to that in 2006?
Give a very brief answer. 1.03. What is the ratio of the CO2 emissions (% of total fuel combustion) of Indonesia in 2002 to that in 2006?
Your answer should be compact. 1.36. What is the ratio of the CO2 emissions (% of total fuel combustion) of Spain in 2002 to that in 2006?
Ensure brevity in your answer.  1.01. What is the ratio of the CO2 emissions (% of total fuel combustion) in High income in 2003 to that in 2004?
Make the answer very short. 1.03. What is the ratio of the CO2 emissions (% of total fuel combustion) of Azerbaijan in 2003 to that in 2004?
Your answer should be compact. 1.05. What is the ratio of the CO2 emissions (% of total fuel combustion) in Indonesia in 2003 to that in 2004?
Provide a short and direct response. 1.01. What is the ratio of the CO2 emissions (% of total fuel combustion) in Spain in 2003 to that in 2004?
Ensure brevity in your answer.  0.98. What is the ratio of the CO2 emissions (% of total fuel combustion) of High income in 2003 to that in 2005?
Provide a succinct answer. 1.05. What is the ratio of the CO2 emissions (% of total fuel combustion) in Azerbaijan in 2003 to that in 2005?
Make the answer very short. 1.08. What is the ratio of the CO2 emissions (% of total fuel combustion) of Indonesia in 2003 to that in 2005?
Keep it short and to the point. 1.07. What is the ratio of the CO2 emissions (% of total fuel combustion) in Spain in 2003 to that in 2005?
Offer a terse response. 0.98. What is the ratio of the CO2 emissions (% of total fuel combustion) of High income in 2003 to that in 2006?
Provide a succinct answer. 1.09. What is the ratio of the CO2 emissions (% of total fuel combustion) in Azerbaijan in 2003 to that in 2006?
Provide a short and direct response. 1.06. What is the ratio of the CO2 emissions (% of total fuel combustion) in Indonesia in 2003 to that in 2006?
Your response must be concise. 1.26. What is the ratio of the CO2 emissions (% of total fuel combustion) of Spain in 2003 to that in 2006?
Offer a very short reply. 1.02. What is the ratio of the CO2 emissions (% of total fuel combustion) of Azerbaijan in 2004 to that in 2005?
Your answer should be compact. 1.03. What is the ratio of the CO2 emissions (% of total fuel combustion) in High income in 2004 to that in 2006?
Give a very brief answer. 1.06. What is the ratio of the CO2 emissions (% of total fuel combustion) in Azerbaijan in 2004 to that in 2006?
Your answer should be compact. 1.01. What is the ratio of the CO2 emissions (% of total fuel combustion) in Indonesia in 2004 to that in 2006?
Give a very brief answer. 1.24. What is the ratio of the CO2 emissions (% of total fuel combustion) of Spain in 2004 to that in 2006?
Your answer should be compact. 1.04. What is the ratio of the CO2 emissions (% of total fuel combustion) of High income in 2005 to that in 2006?
Offer a terse response. 1.05. What is the ratio of the CO2 emissions (% of total fuel combustion) in Azerbaijan in 2005 to that in 2006?
Make the answer very short. 0.98. What is the ratio of the CO2 emissions (% of total fuel combustion) in Indonesia in 2005 to that in 2006?
Ensure brevity in your answer.  1.17. What is the ratio of the CO2 emissions (% of total fuel combustion) of Spain in 2005 to that in 2006?
Your response must be concise. 1.03. What is the difference between the highest and the second highest CO2 emissions (% of total fuel combustion) of High income?
Provide a short and direct response. 0.09. What is the difference between the highest and the second highest CO2 emissions (% of total fuel combustion) in Azerbaijan?
Give a very brief answer. 0.49. What is the difference between the highest and the second highest CO2 emissions (% of total fuel combustion) of Indonesia?
Your answer should be very brief. 0.69. What is the difference between the highest and the second highest CO2 emissions (% of total fuel combustion) in Spain?
Your response must be concise. 0.09. What is the difference between the highest and the lowest CO2 emissions (% of total fuel combustion) in High income?
Make the answer very short. 1.13. What is the difference between the highest and the lowest CO2 emissions (% of total fuel combustion) in Azerbaijan?
Your answer should be very brief. 2.6. What is the difference between the highest and the lowest CO2 emissions (% of total fuel combustion) in Indonesia?
Your answer should be very brief. 3.44. What is the difference between the highest and the lowest CO2 emissions (% of total fuel combustion) in Spain?
Provide a succinct answer. 0.38. 